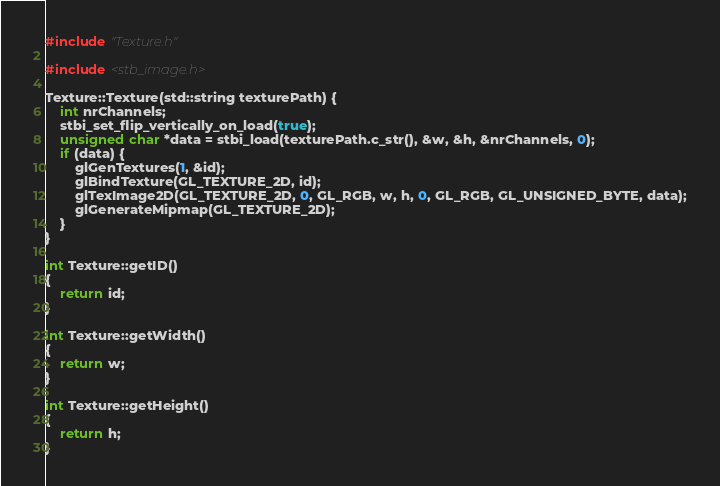<code> <loc_0><loc_0><loc_500><loc_500><_C++_>#include "Texture.h"

#include <stb_image.h>

Texture::Texture(std::string texturePath) {
	int nrChannels;
	stbi_set_flip_vertically_on_load(true);
	unsigned char *data = stbi_load(texturePath.c_str(), &w, &h, &nrChannels, 0);
	if (data) {
		glGenTextures(1, &id);
		glBindTexture(GL_TEXTURE_2D, id);
		glTexImage2D(GL_TEXTURE_2D, 0, GL_RGB, w, h, 0, GL_RGB, GL_UNSIGNED_BYTE, data);
		glGenerateMipmap(GL_TEXTURE_2D);
	}
}

int Texture::getID()
{
	return id;
}

int Texture::getWidth()
{
	return w;
}

int Texture::getHeight()
{
	return h;
}
</code> 